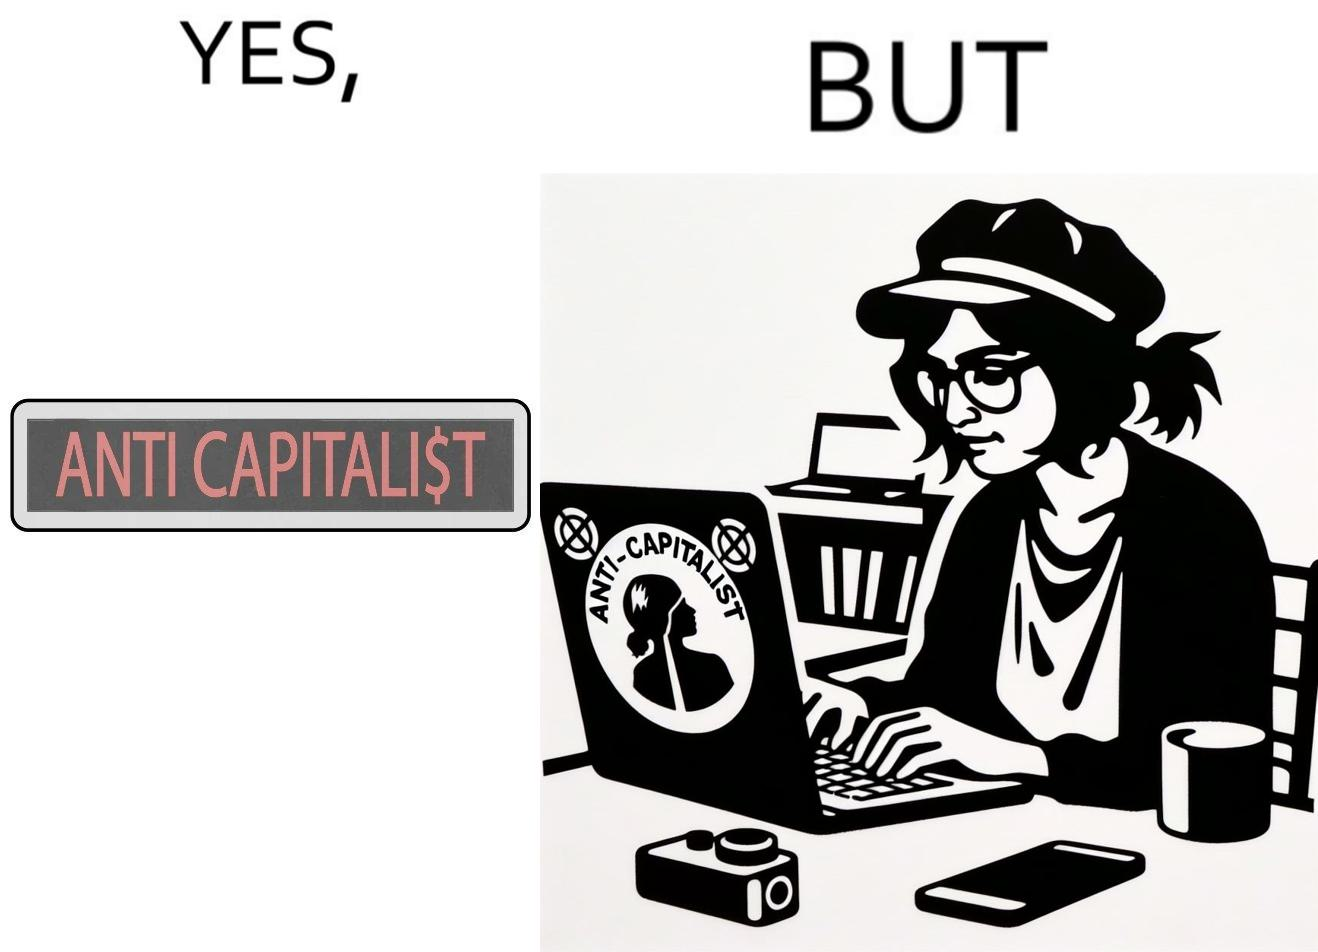Compare the left and right sides of this image. In the left part of the image: The image is just text with red font saying anti capitalist where the letter s in the capitalist is replaced with the dollar sign. In the right part of the image: A woman wearing glasses and a cap using laptop with the sign anti capitalist on it. The women has a phone, a camera and a cup on the table. She is working. 